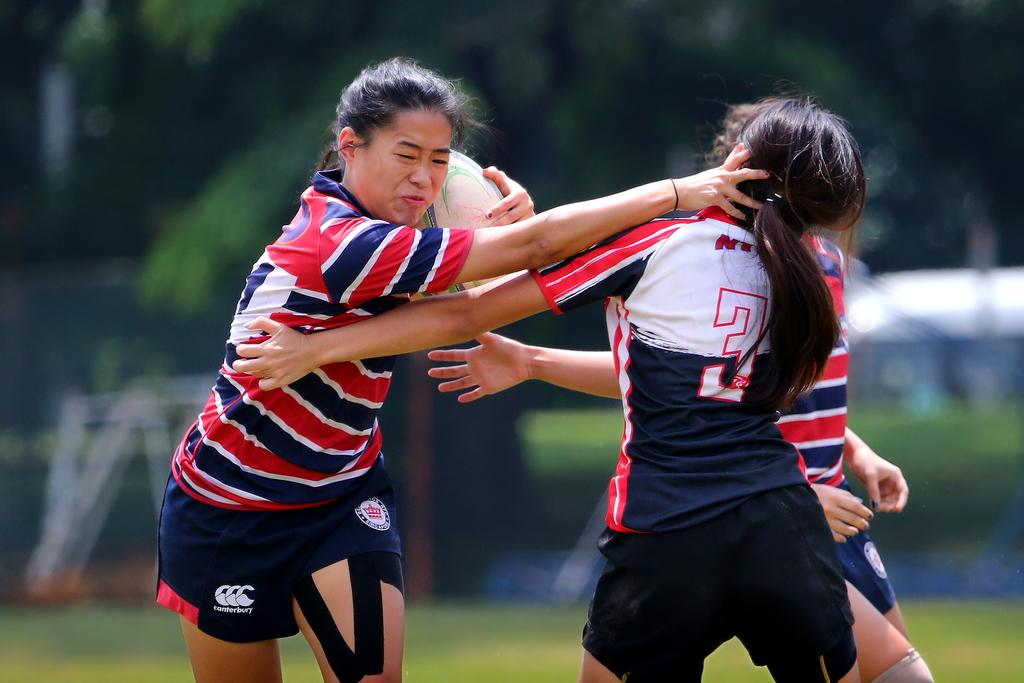How many people are in the image? There are people in the image, but the exact number is not specified. What type of clothing are the people wearing? The people are wearing T-shirts and shorts. Can you describe the object being held by one of the people? One person is holding an object, but the specific object is not mentioned. What can be seen beneath the people in the image? The ground is visible in the image. How would you describe the background of the image? The background is blurred. What is the chance of the people in the image winning a race? There is no information about a race or any chances in the image. 